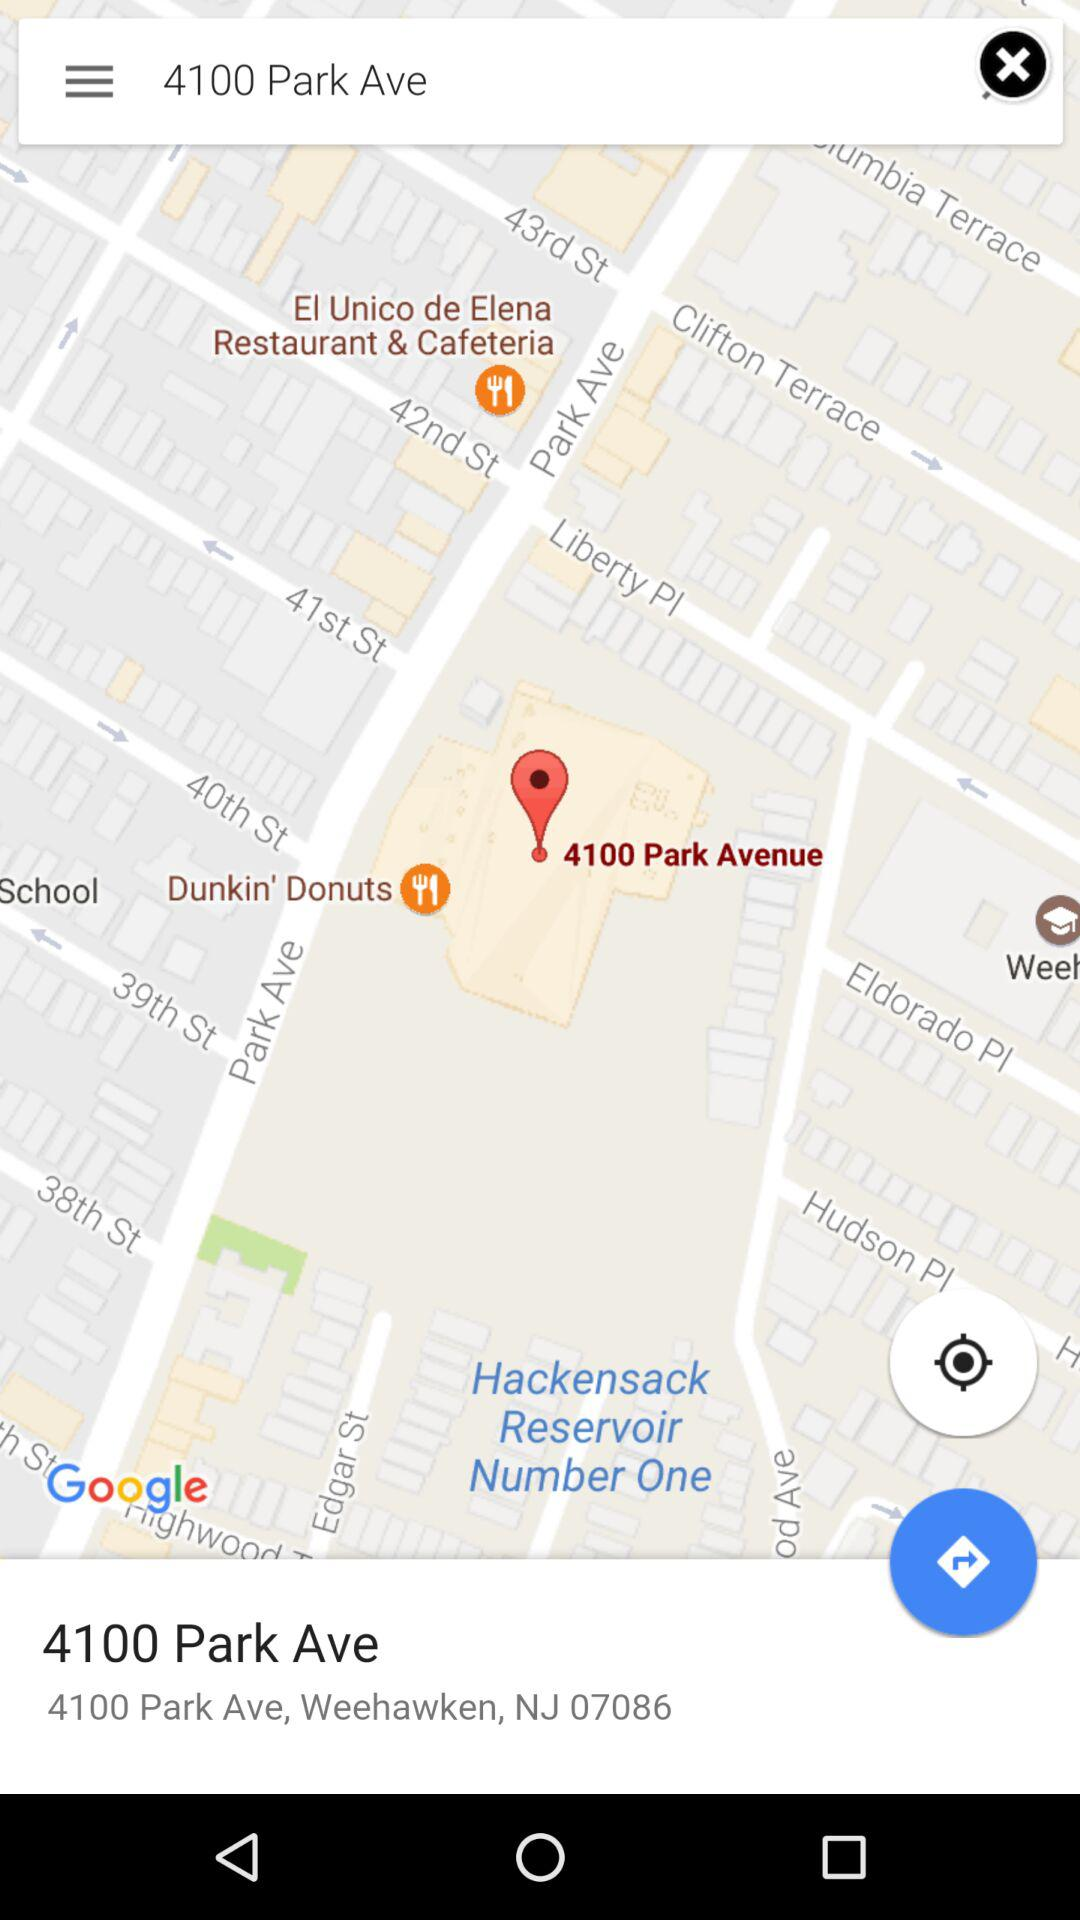What is the destination address shown on the screen? The destination address is 4100 Park Ave, Weehawken, NJ 07086. 